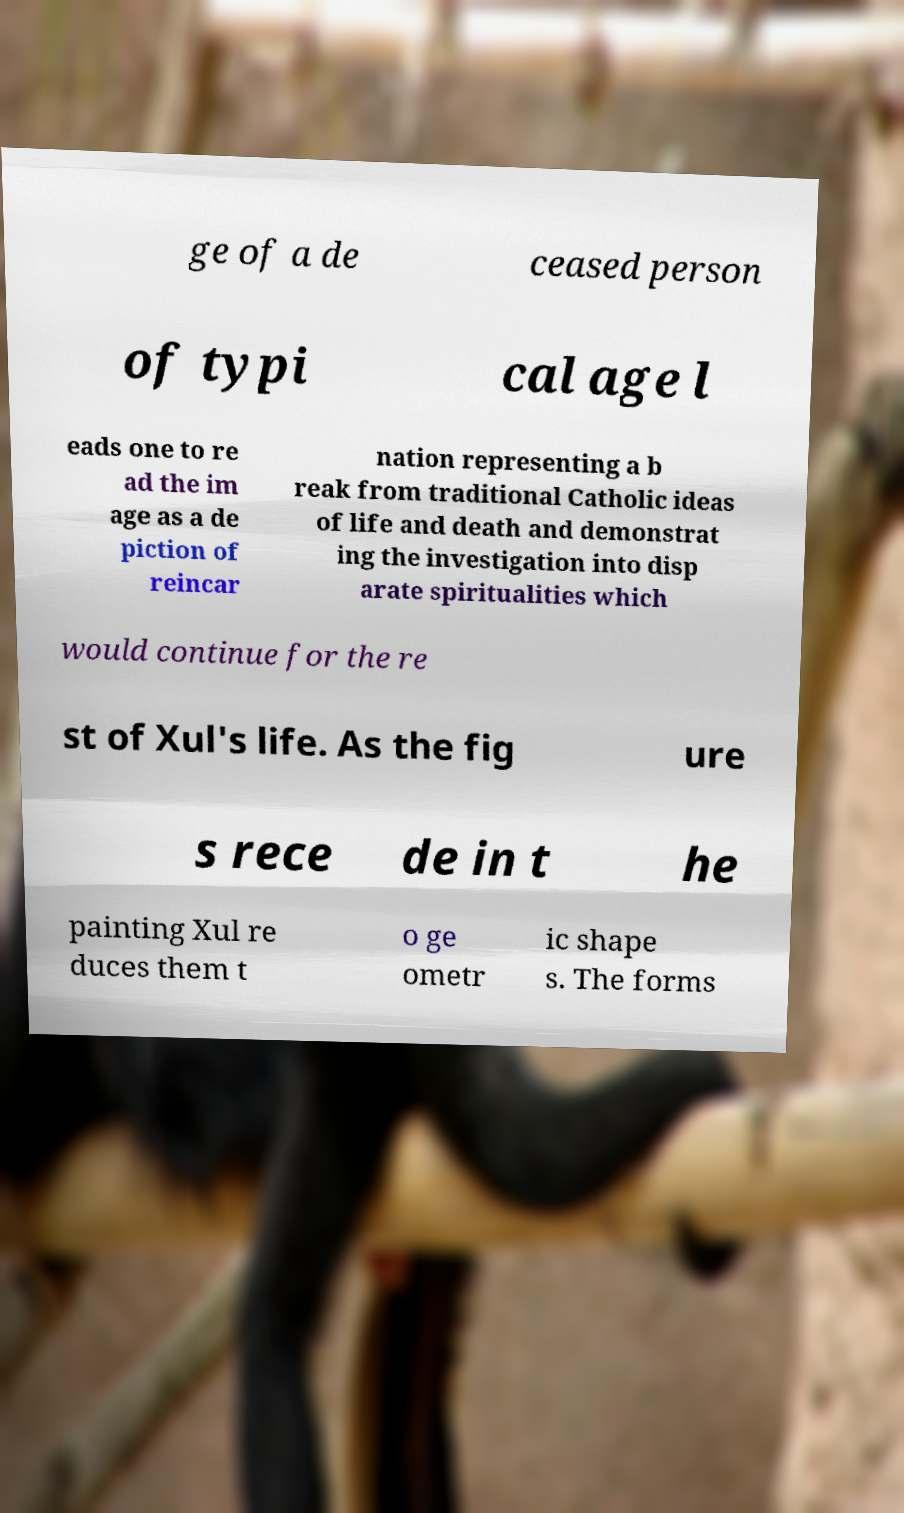Please read and relay the text visible in this image. What does it say? ge of a de ceased person of typi cal age l eads one to re ad the im age as a de piction of reincar nation representing a b reak from traditional Catholic ideas of life and death and demonstrat ing the investigation into disp arate spiritualities which would continue for the re st of Xul's life. As the fig ure s rece de in t he painting Xul re duces them t o ge ometr ic shape s. The forms 